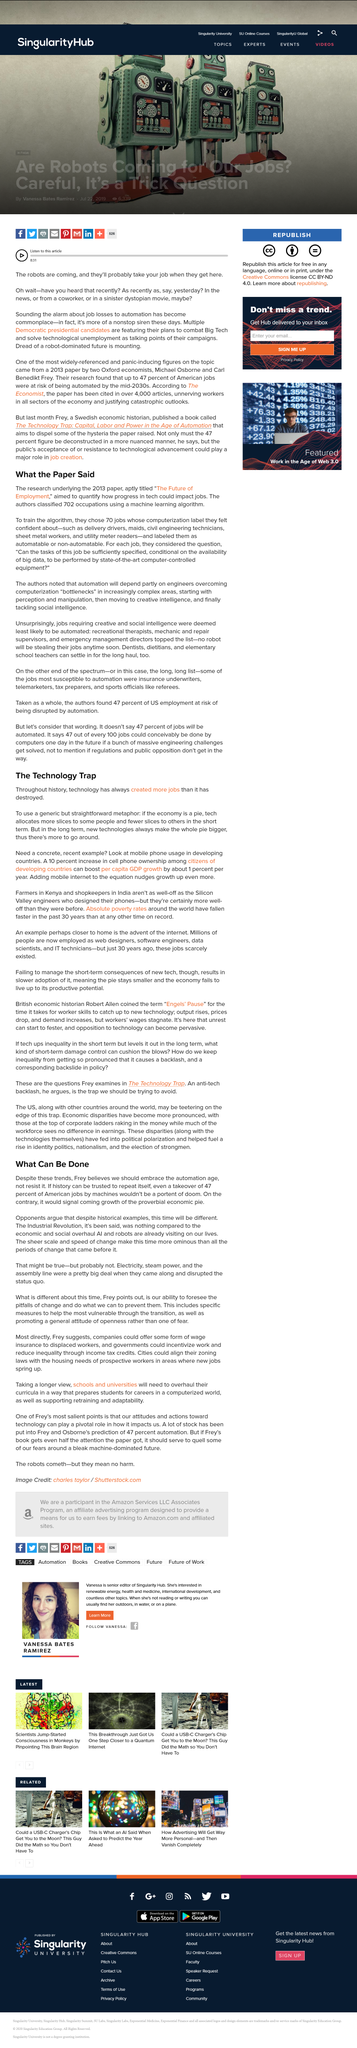Specify some key components in this picture. The research paper was titled 'The Future of Employment'. Pie is the dessert used in the technology-related metaphor. The research paper was released in 2013. The phrase "technologies always make the whole pie bigger" does not mean that technology destroys more jobs than it creates. The speaker asserts that the concept of "embracing the automation age, not resisting it" should be adopted. This is in agreement with the idea that humanity should not resist the advancing technology, but rather, should embrace it and find ways to make the best use of it. 